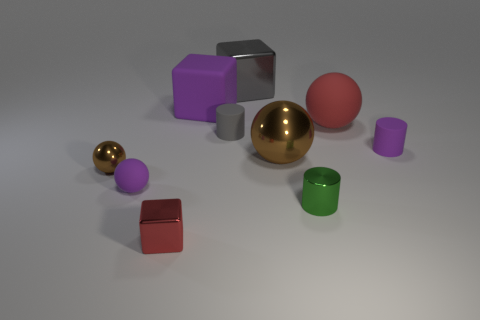How many brown spheres must be subtracted to get 1 brown spheres? 1 Subtract all large cubes. How many cubes are left? 1 Subtract all cylinders. How many objects are left? 7 Subtract 2 cylinders. How many cylinders are left? 1 Subtract all cyan cylinders. How many brown spheres are left? 2 Add 8 small purple objects. How many small purple objects exist? 10 Subtract all gray cylinders. How many cylinders are left? 2 Subtract 0 brown cylinders. How many objects are left? 10 Subtract all brown balls. Subtract all green cylinders. How many balls are left? 2 Subtract all large red shiny objects. Subtract all red shiny cubes. How many objects are left? 9 